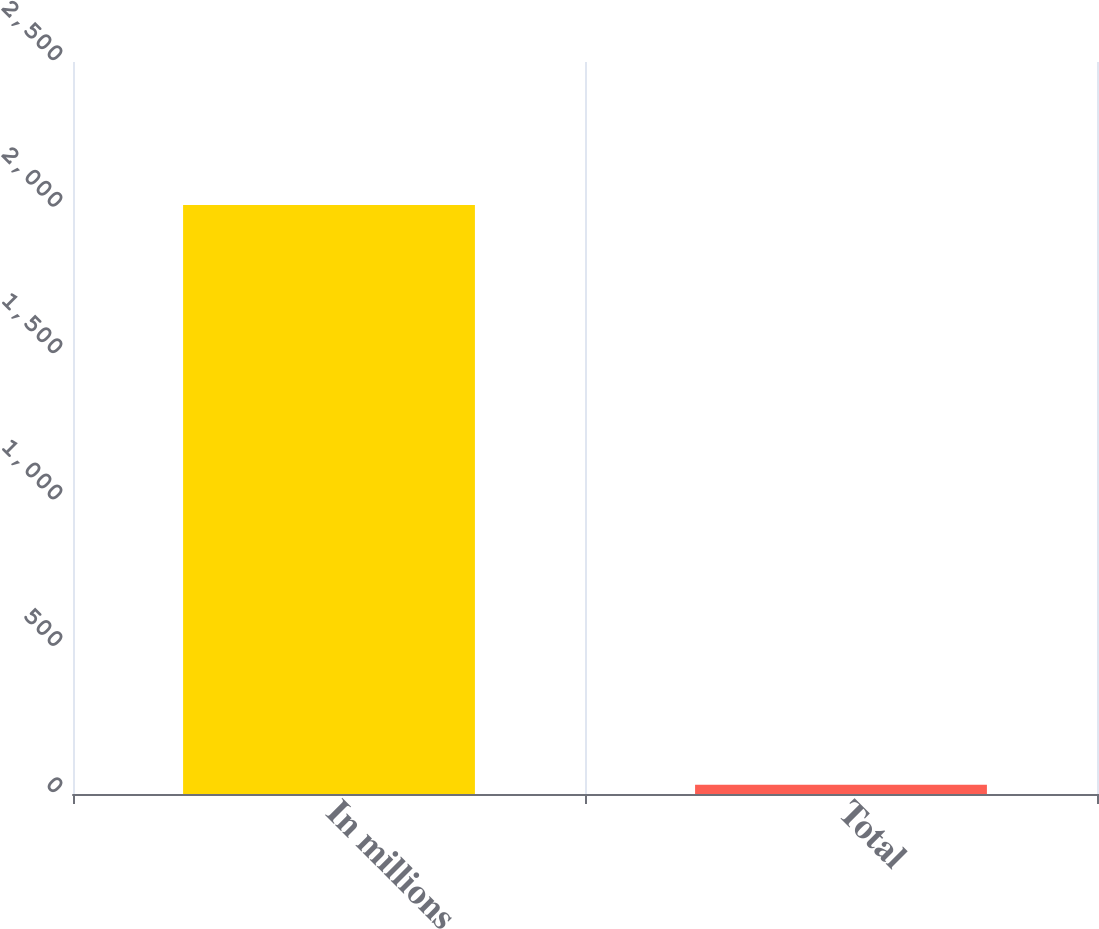Convert chart to OTSL. <chart><loc_0><loc_0><loc_500><loc_500><bar_chart><fcel>In millions<fcel>Total<nl><fcel>2012<fcel>32<nl></chart> 